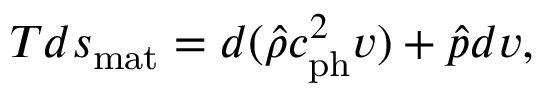<formula> <loc_0><loc_0><loc_500><loc_500>T d s _ { m a t } = d ( \hat { \rho } c _ { p h } ^ { 2 } v ) + \hat { p } d v ,</formula> 